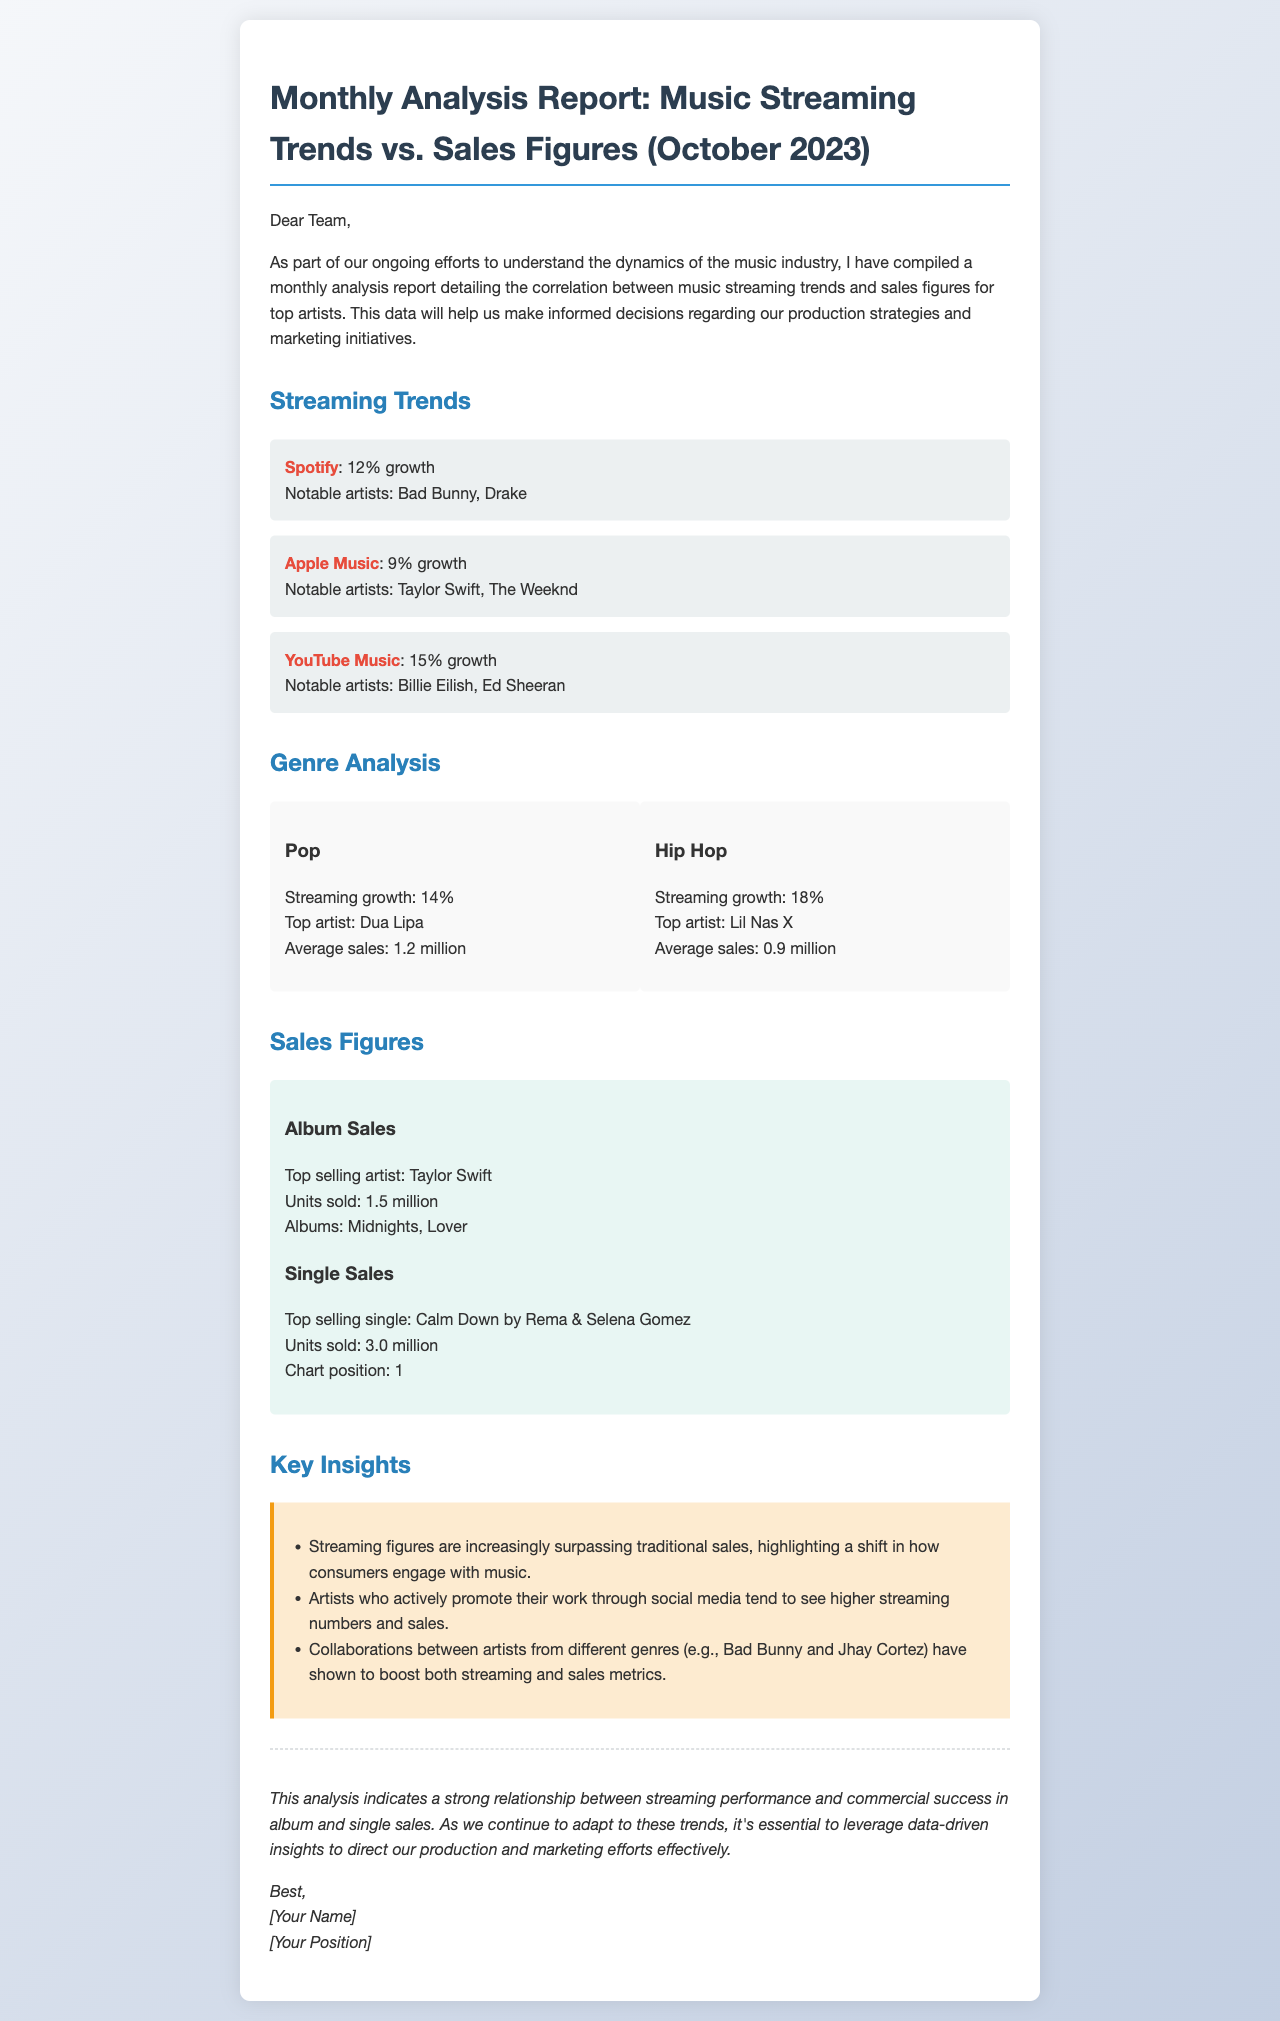What was the growth percentage for Spotify? The document lists Spotify's growth percentage in the streaming trends section, which is 12%.
Answer: 12% Who is the top-selling single artist mentioned? The document states the top-selling single is by Rema & Selena Gomez, making them the top-selling single artists.
Answer: Rema & Selena Gomez What is the average sales figure for the Hip Hop genre? The Hip Hop genre analysis includes an average sales figure of 0.9 million.
Answer: 0.9 million Which platform had the highest growth percentage? By comparing the growth percentages listed, YouTube Music shows the highest growth at 15%.
Answer: YouTube Music What is a key insight regarding artist collaboration? The document notes that collaborations have shown to boost both streaming and sales metrics.
Answer: Boost both streaming and sales metrics What albums contributed to Taylor Swift's top sales? The document specifies that her top-selling albums are "Midnights" and "Lover."
Answer: Midnights, Lover Which genre had the highest streaming growth percentage? The document reveals that the Hip Hop genre had the highest streaming growth percentage of 18%.
Answer: 18% What is the chart position of the top-selling single? The document states that the top-selling single, "Calm Down," reached position 1 on the charts.
Answer: 1 